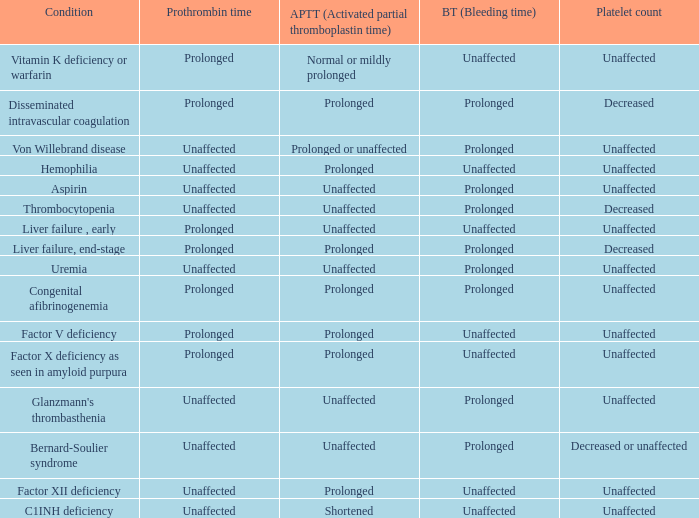Which Platelet count has a Condition of bernard-soulier syndrome? Decreased or unaffected. 